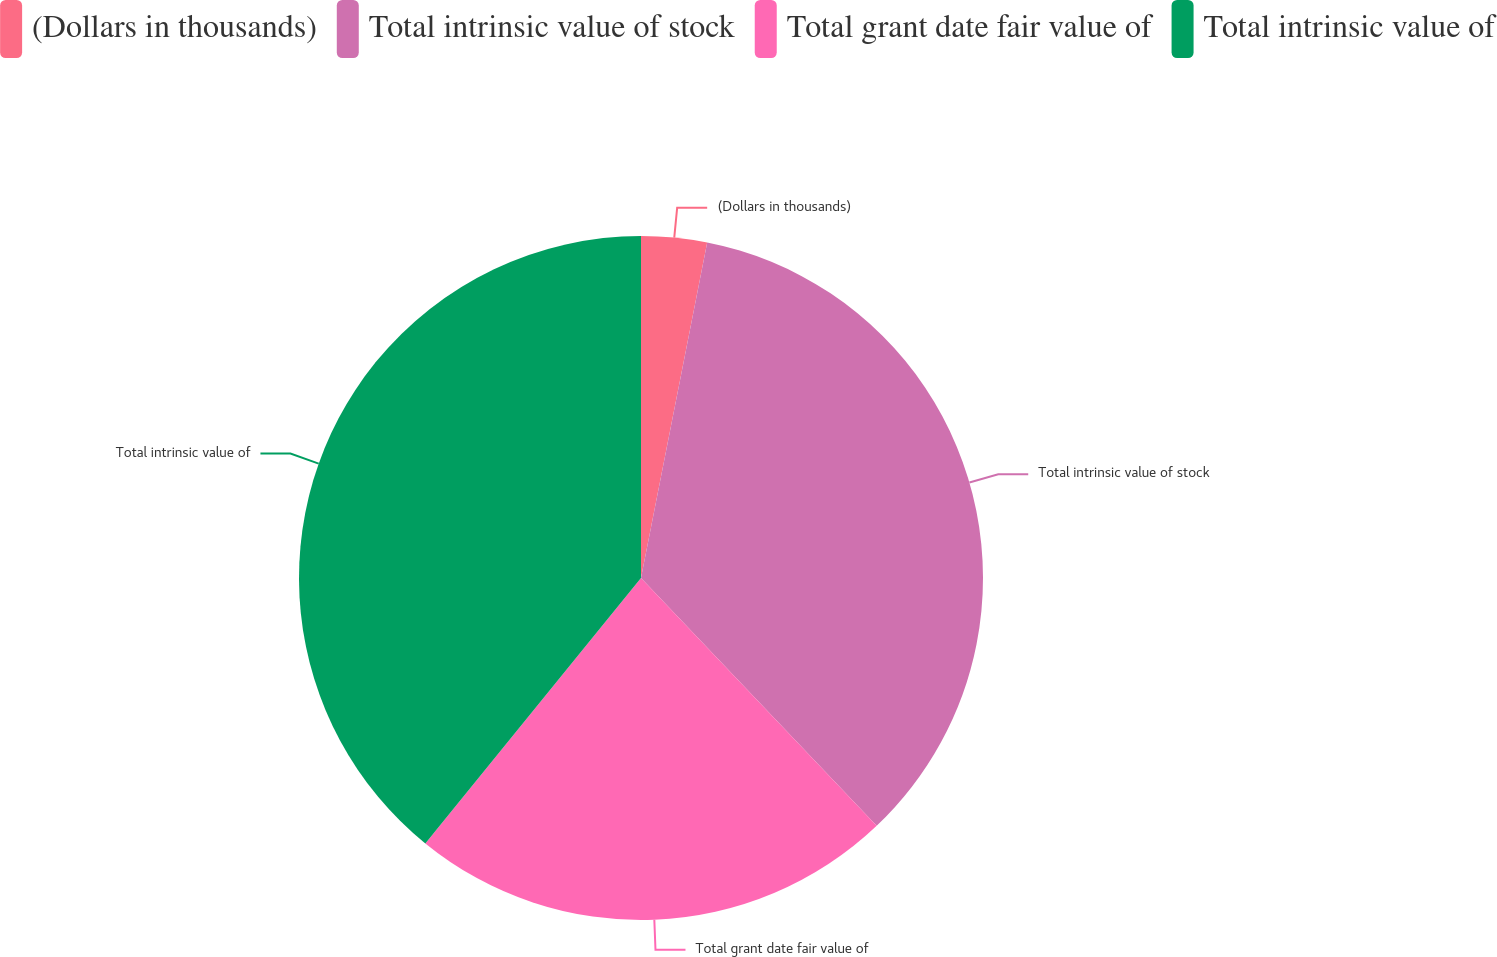<chart> <loc_0><loc_0><loc_500><loc_500><pie_chart><fcel>(Dollars in thousands)<fcel>Total intrinsic value of stock<fcel>Total grant date fair value of<fcel>Total intrinsic value of<nl><fcel>3.1%<fcel>34.8%<fcel>22.96%<fcel>39.14%<nl></chart> 